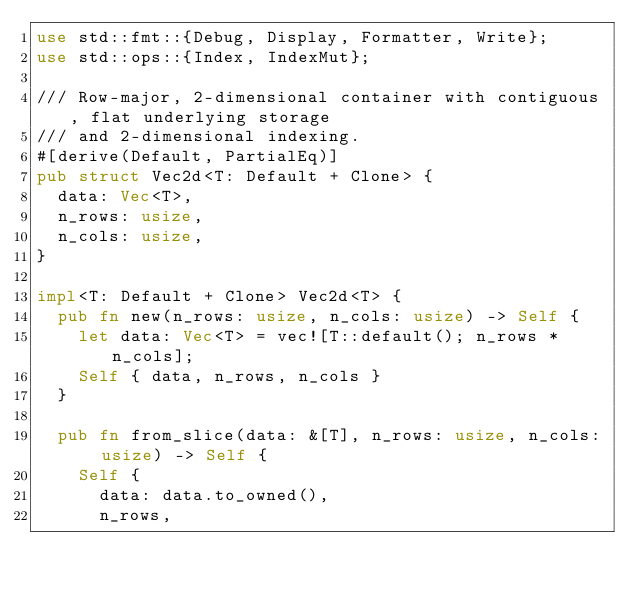<code> <loc_0><loc_0><loc_500><loc_500><_Rust_>use std::fmt::{Debug, Display, Formatter, Write};
use std::ops::{Index, IndexMut};

/// Row-major, 2-dimensional container with contiguous, flat underlying storage
/// and 2-dimensional indexing.
#[derive(Default, PartialEq)]
pub struct Vec2d<T: Default + Clone> {
  data: Vec<T>,
  n_rows: usize,
  n_cols: usize,
}

impl<T: Default + Clone> Vec2d<T> {
  pub fn new(n_rows: usize, n_cols: usize) -> Self {
    let data: Vec<T> = vec![T::default(); n_rows * n_cols];
    Self { data, n_rows, n_cols }
  }

  pub fn from_slice(data: &[T], n_rows: usize, n_cols: usize) -> Self {
    Self {
      data: data.to_owned(),
      n_rows,</code> 